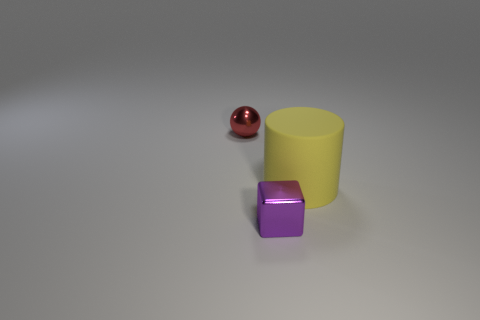Add 2 small cyan rubber blocks. How many objects exist? 5 Subtract all blocks. How many objects are left? 2 Add 3 small red rubber cubes. How many small red rubber cubes exist? 3 Subtract 0 brown blocks. How many objects are left? 3 Subtract all red metallic objects. Subtract all cyan spheres. How many objects are left? 2 Add 1 large yellow matte cylinders. How many large yellow matte cylinders are left? 2 